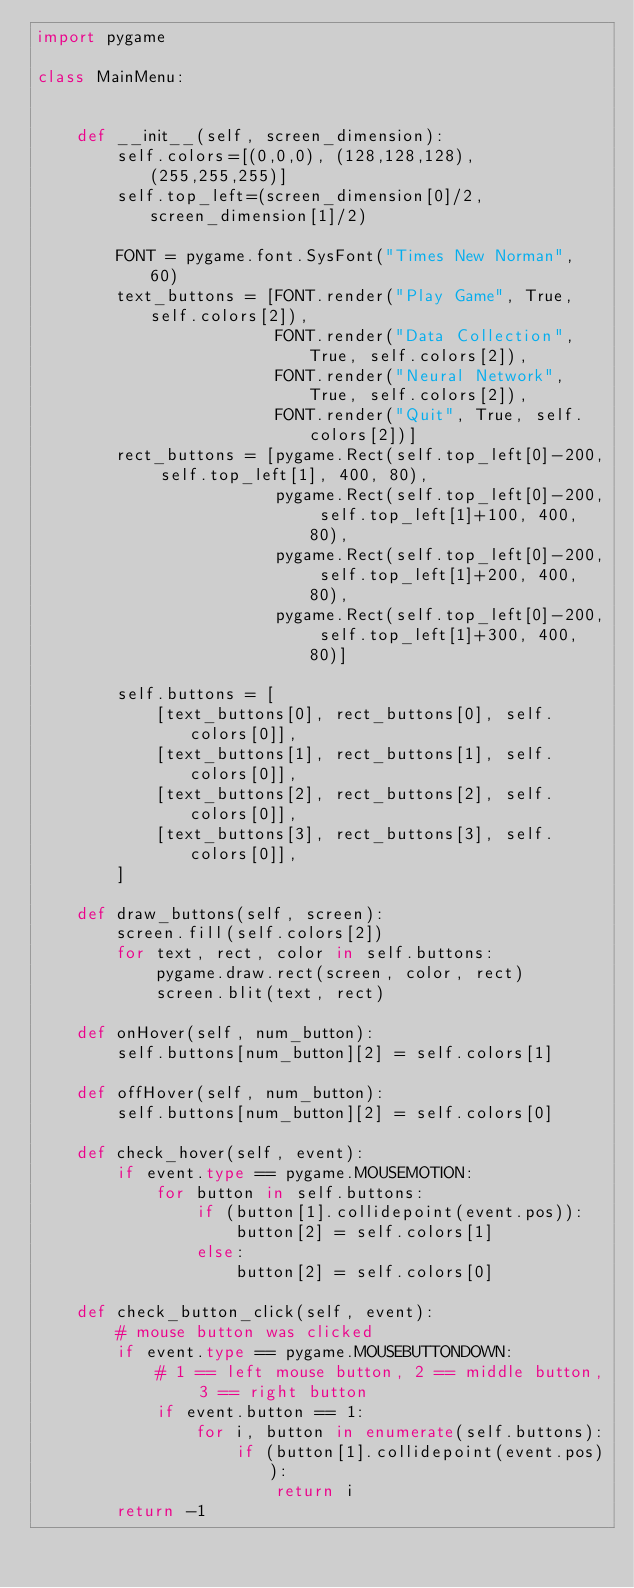<code> <loc_0><loc_0><loc_500><loc_500><_Python_>import pygame

class MainMenu:


    def __init__(self, screen_dimension):
        self.colors=[(0,0,0), (128,128,128), (255,255,255)]
        self.top_left=(screen_dimension[0]/2, screen_dimension[1]/2)
        
        FONT = pygame.font.SysFont("Times New Norman", 60)
        text_buttons = [FONT.render("Play Game", True, self.colors[2]), 
                        FONT.render("Data Collection", True, self.colors[2]), 
                        FONT.render("Neural Network", True, self.colors[2]), 
                        FONT.render("Quit", True, self.colors[2])]
        rect_buttons = [pygame.Rect(self.top_left[0]-200, self.top_left[1], 400, 80),
                        pygame.Rect(self.top_left[0]-200, self.top_left[1]+100, 400, 80), 
                        pygame.Rect(self.top_left[0]-200, self.top_left[1]+200, 400, 80), 
                        pygame.Rect(self.top_left[0]-200, self.top_left[1]+300, 400, 80)]

        self.buttons = [
            [text_buttons[0], rect_buttons[0], self.colors[0]],
            [text_buttons[1], rect_buttons[1], self.colors[0]],
            [text_buttons[2], rect_buttons[2], self.colors[0]],
            [text_buttons[3], rect_buttons[3], self.colors[0]],
        ]

    def draw_buttons(self, screen):
        screen.fill(self.colors[2])
        for text, rect, color in self.buttons:
            pygame.draw.rect(screen, color, rect)
            screen.blit(text, rect)
    
    def onHover(self, num_button):
        self.buttons[num_button][2] = self.colors[1]
    
    def offHover(self, num_button):
        self.buttons[num_button][2] = self.colors[0]

    def check_hover(self, event):
        if event.type == pygame.MOUSEMOTION:
            for button in self.buttons:
                if (button[1].collidepoint(event.pos)):
                    button[2] = self.colors[1]
                else:
                    button[2] = self.colors[0]

    def check_button_click(self, event):
        # mouse button was clicked
        if event.type == pygame.MOUSEBUTTONDOWN:
            # 1 == left mouse button, 2 == middle button, 3 == right button
            if event.button == 1:
                for i, button in enumerate(self.buttons):
                    if (button[1].collidepoint(event.pos)):
                        return i
        return -1</code> 